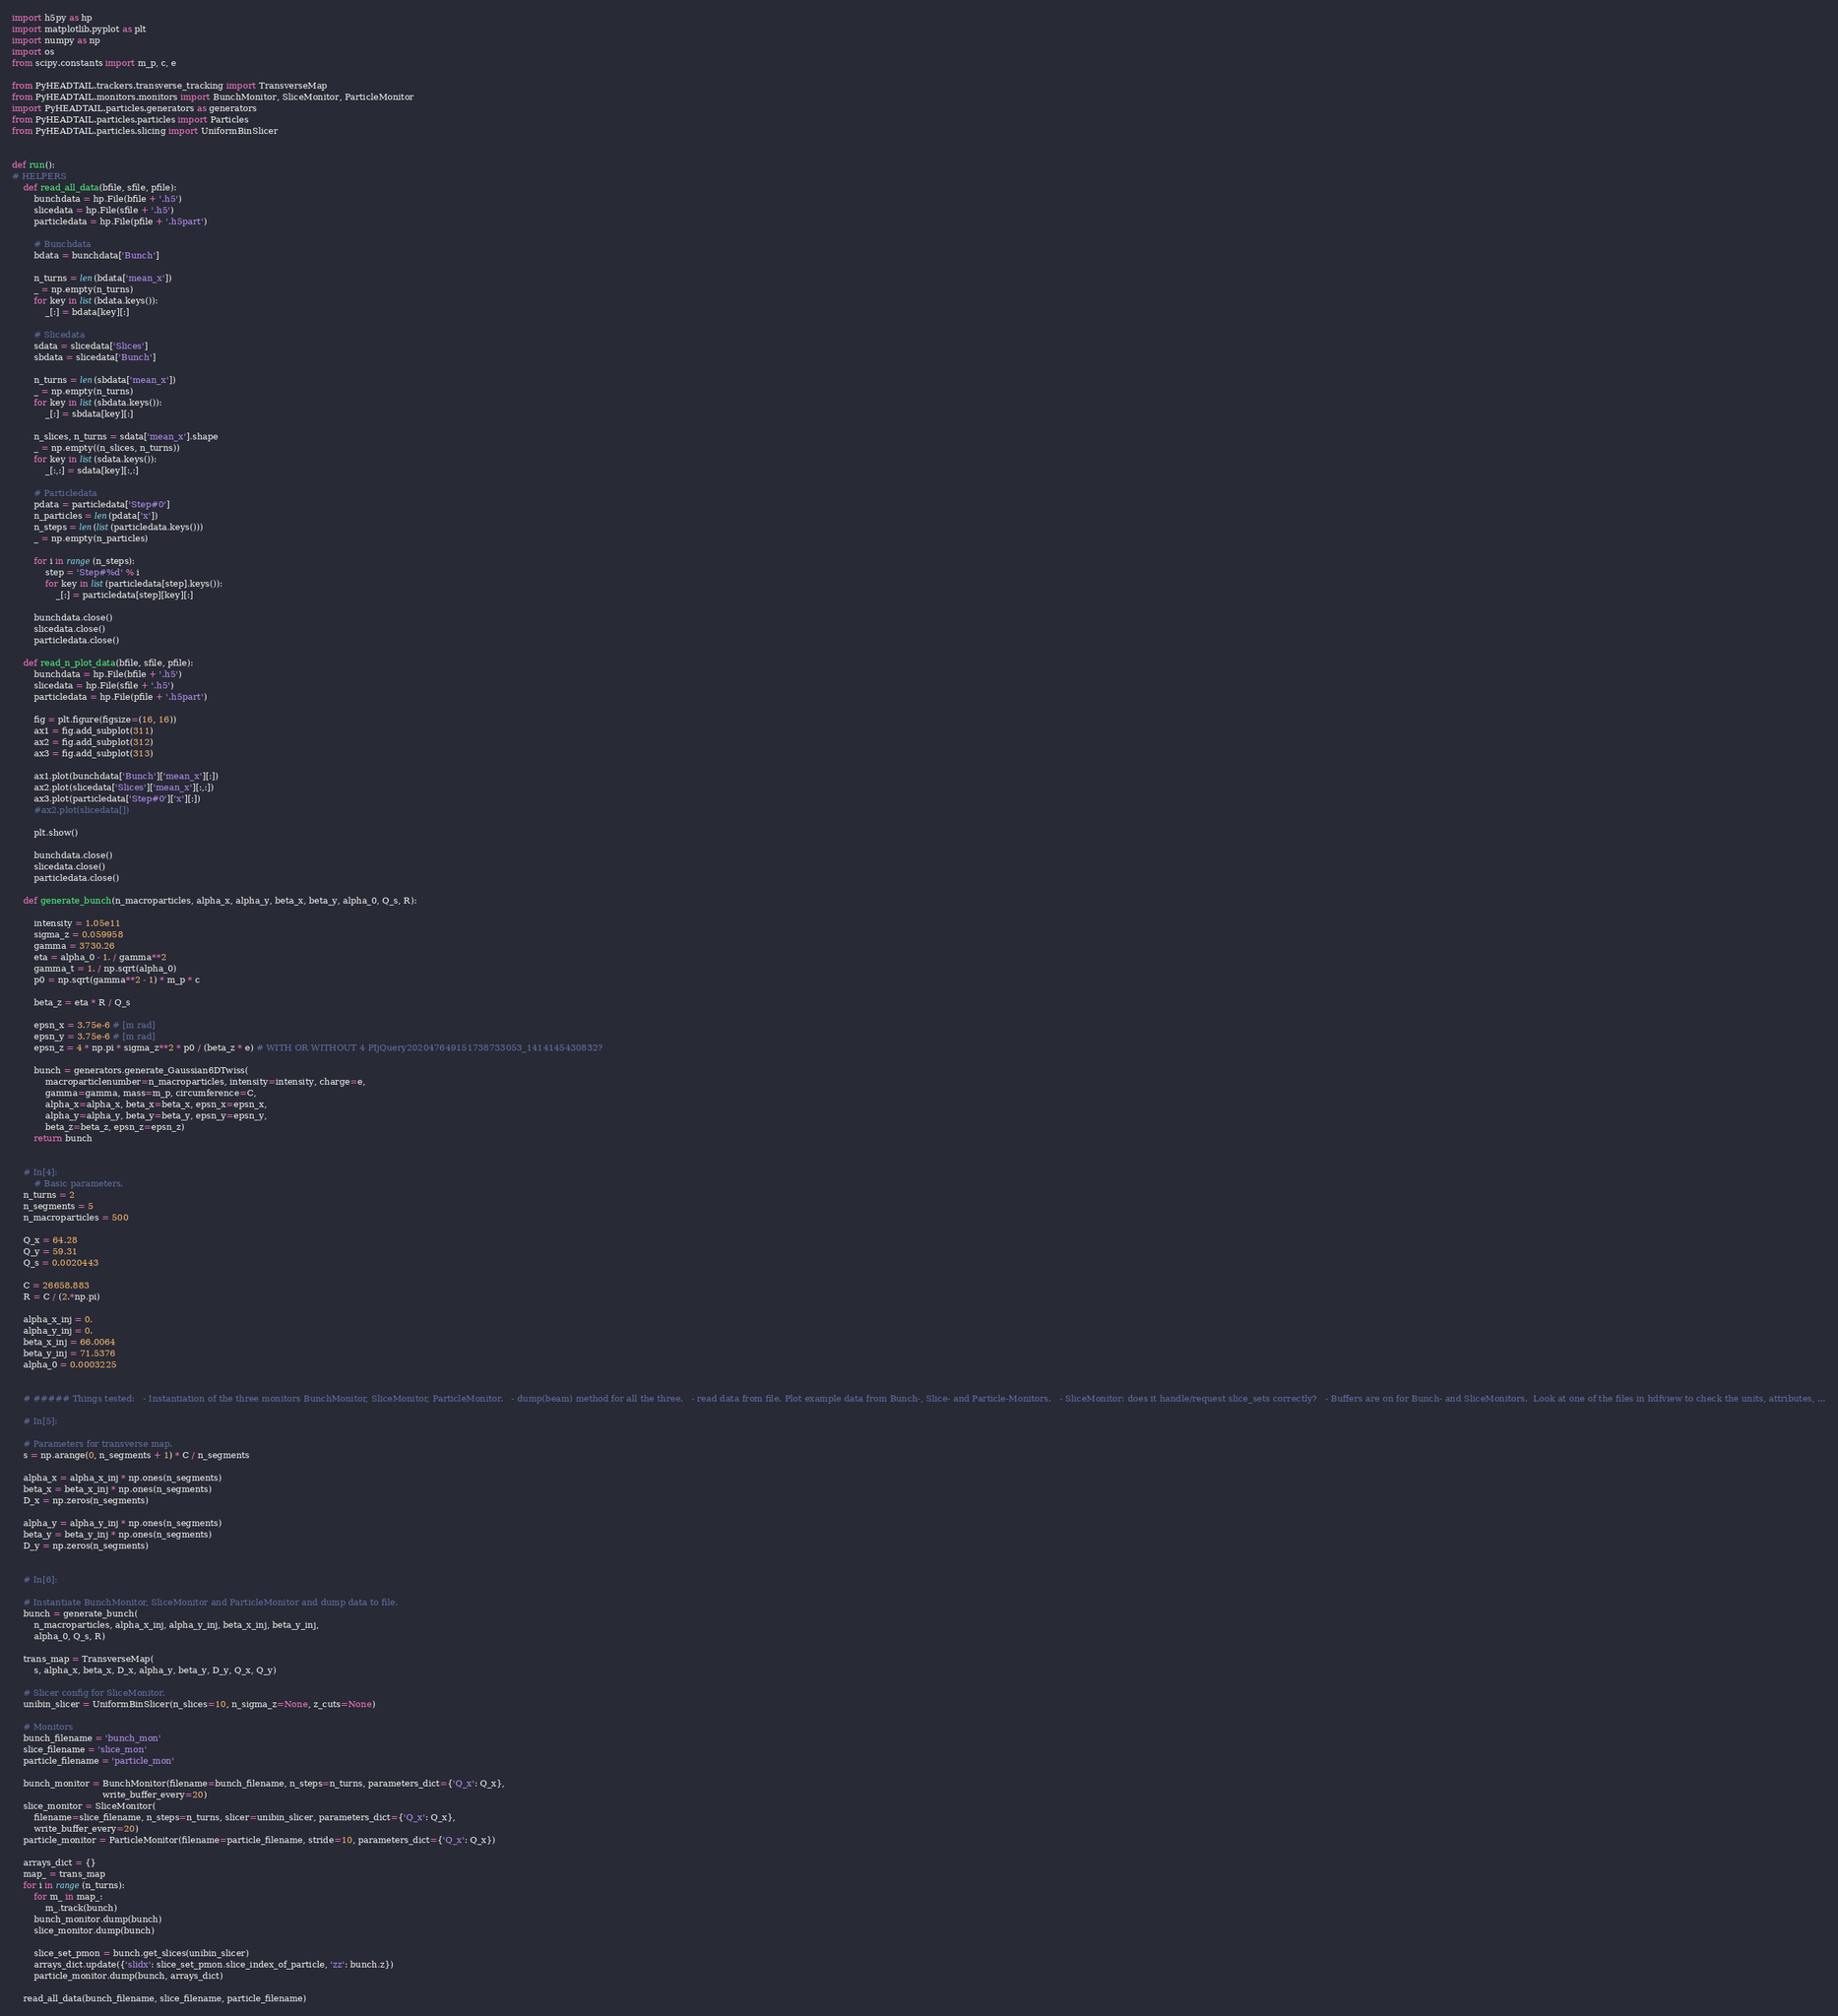Convert code to text. <code><loc_0><loc_0><loc_500><loc_500><_Python_>import h5py as hp
import matplotlib.pyplot as plt
import numpy as np
import os
from scipy.constants import m_p, c, e

from PyHEADTAIL.trackers.transverse_tracking import TransverseMap
from PyHEADTAIL.monitors.monitors import BunchMonitor, SliceMonitor, ParticleMonitor
import PyHEADTAIL.particles.generators as generators
from PyHEADTAIL.particles.particles import Particles
from PyHEADTAIL.particles.slicing import UniformBinSlicer


def run():
# HELPERS
    def read_all_data(bfile, sfile, pfile):
        bunchdata = hp.File(bfile + '.h5')
        slicedata = hp.File(sfile + '.h5')
        particledata = hp.File(pfile + '.h5part')

        # Bunchdata
        bdata = bunchdata['Bunch']

        n_turns = len(bdata['mean_x'])
        _ = np.empty(n_turns)
        for key in list(bdata.keys()):
            _[:] = bdata[key][:]

        # Slicedata
        sdata = slicedata['Slices']
        sbdata = slicedata['Bunch']

        n_turns = len(sbdata['mean_x'])
        _ = np.empty(n_turns)
        for key in list(sbdata.keys()):
            _[:] = sbdata[key][:]

        n_slices, n_turns = sdata['mean_x'].shape
        _ = np.empty((n_slices, n_turns))
        for key in list(sdata.keys()):
            _[:,:] = sdata[key][:,:]

        # Particledata
        pdata = particledata['Step#0']
        n_particles = len(pdata['x'])
        n_steps = len(list(particledata.keys()))
        _ = np.empty(n_particles)

        for i in range(n_steps):
            step = 'Step#%d' % i
            for key in list(particledata[step].keys()):
                _[:] = particledata[step][key][:]

        bunchdata.close()
        slicedata.close()
        particledata.close()

    def read_n_plot_data(bfile, sfile, pfile):
        bunchdata = hp.File(bfile + '.h5')
        slicedata = hp.File(sfile + '.h5')
        particledata = hp.File(pfile + '.h5part')

        fig = plt.figure(figsize=(16, 16))
        ax1 = fig.add_subplot(311)
        ax2 = fig.add_subplot(312)
        ax3 = fig.add_subplot(313)

        ax1.plot(bunchdata['Bunch']['mean_x'][:])
        ax2.plot(slicedata['Slices']['mean_x'][:,:])
        ax3.plot(particledata['Step#0']['x'][:])
        #ax2.plot(slicedata[])

        plt.show()

        bunchdata.close()
        slicedata.close()
        particledata.close()

    def generate_bunch(n_macroparticles, alpha_x, alpha_y, beta_x, beta_y, alpha_0, Q_s, R):

        intensity = 1.05e11
        sigma_z = 0.059958
        gamma = 3730.26
        eta = alpha_0 - 1. / gamma**2
        gamma_t = 1. / np.sqrt(alpha_0)
        p0 = np.sqrt(gamma**2 - 1) * m_p * c

        beta_z = eta * R / Q_s

        epsn_x = 3.75e-6 # [m rad]
        epsn_y = 3.75e-6 # [m rad]
        epsn_z = 4 * np.pi * sigma_z**2 * p0 / (beta_z * e) # WITH OR WITHOUT 4 PIjQuery202047649151738733053_1414145430832?

        bunch = generators.generate_Gaussian6DTwiss(
            macroparticlenumber=n_macroparticles, intensity=intensity, charge=e,
            gamma=gamma, mass=m_p, circumference=C,
            alpha_x=alpha_x, beta_x=beta_x, epsn_x=epsn_x,
            alpha_y=alpha_y, beta_y=beta_y, epsn_y=epsn_y,
            beta_z=beta_z, epsn_z=epsn_z)
        return bunch


    # In[4]:
        # Basic parameters.
    n_turns = 2
    n_segments = 5
    n_macroparticles = 500

    Q_x = 64.28
    Q_y = 59.31
    Q_s = 0.0020443

    C = 26658.883
    R = C / (2.*np.pi)

    alpha_x_inj = 0.
    alpha_y_inj = 0.
    beta_x_inj = 66.0064
    beta_y_inj = 71.5376
    alpha_0 = 0.0003225


    # ##### Things tested:   - Instantiation of the three monitors BunchMonitor, SliceMonitor, ParticleMonitor.   - dump(beam) method for all the three.   - read data from file. Plot example data from Bunch-, Slice- and Particle-Monitors.   - SliceMonitor: does it handle/request slice_sets correctly?   - Buffers are on for Bunch- and SliceMonitors.  Look at one of the files in hdfview to check the units, attributes, ...

    # In[5]:

    # Parameters for transverse map.
    s = np.arange(0, n_segments + 1) * C / n_segments

    alpha_x = alpha_x_inj * np.ones(n_segments)
    beta_x = beta_x_inj * np.ones(n_segments)
    D_x = np.zeros(n_segments)

    alpha_y = alpha_y_inj * np.ones(n_segments)
    beta_y = beta_y_inj * np.ones(n_segments)
    D_y = np.zeros(n_segments)


    # In[6]:

    # Instantiate BunchMonitor, SliceMonitor and ParticleMonitor and dump data to file.
    bunch = generate_bunch(
        n_macroparticles, alpha_x_inj, alpha_y_inj, beta_x_inj, beta_y_inj,
        alpha_0, Q_s, R)

    trans_map = TransverseMap(
        s, alpha_x, beta_x, D_x, alpha_y, beta_y, D_y, Q_x, Q_y)

    # Slicer config for SliceMonitor.
    unibin_slicer = UniformBinSlicer(n_slices=10, n_sigma_z=None, z_cuts=None)

    # Monitors
    bunch_filename = 'bunch_mon'
    slice_filename = 'slice_mon'
    particle_filename = 'particle_mon'

    bunch_monitor = BunchMonitor(filename=bunch_filename, n_steps=n_turns, parameters_dict={'Q_x': Q_x},
                                 write_buffer_every=20)
    slice_monitor = SliceMonitor(
        filename=slice_filename, n_steps=n_turns, slicer=unibin_slicer, parameters_dict={'Q_x': Q_x},
        write_buffer_every=20)
    particle_monitor = ParticleMonitor(filename=particle_filename, stride=10, parameters_dict={'Q_x': Q_x})

    arrays_dict = {}
    map_ = trans_map
    for i in range(n_turns):
        for m_ in map_:
            m_.track(bunch)
        bunch_monitor.dump(bunch)
        slice_monitor.dump(bunch)

        slice_set_pmon = bunch.get_slices(unibin_slicer)
        arrays_dict.update({'slidx': slice_set_pmon.slice_index_of_particle, 'zz': bunch.z})
        particle_monitor.dump(bunch, arrays_dict)

    read_all_data(bunch_filename, slice_filename, particle_filename)
</code> 